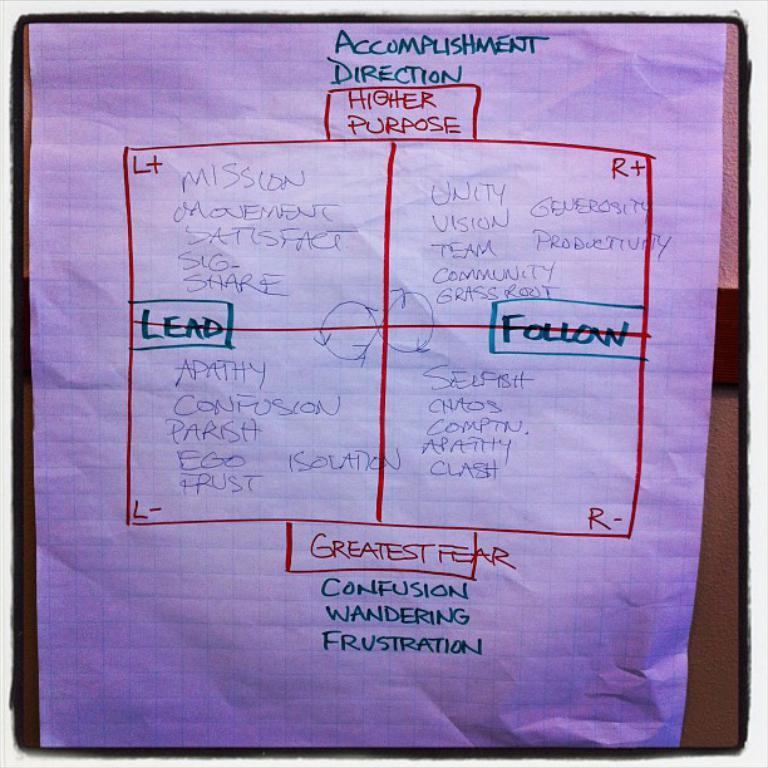Provide a one-sentence caption for the provided image. A white big piece of paper that is an accomplishment direction. 